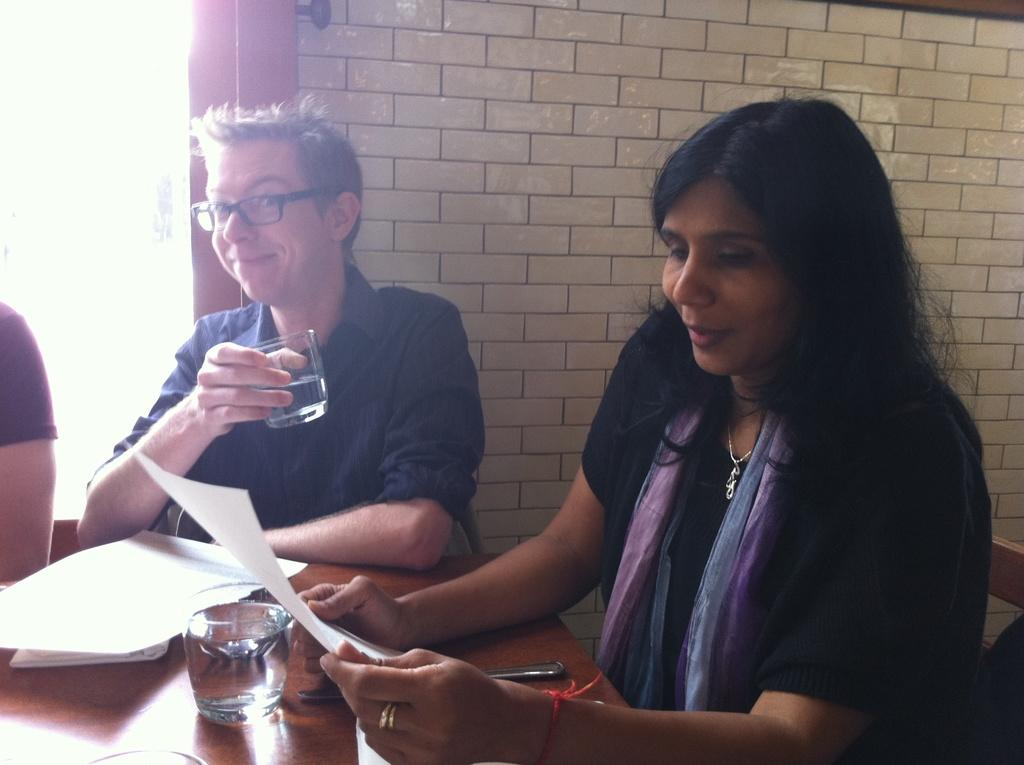What is the main object in the image? There is a table in the image. What items can be seen on the table? Papers and a glass are present on the table. How many people are in the image? There are two persons in the image. What are the people doing in the image? One person is holding a glass, and the other person is holding a paper. What sound can be heard coming from the baby in the image? There is no baby present in the image, so no sound can be heard. 